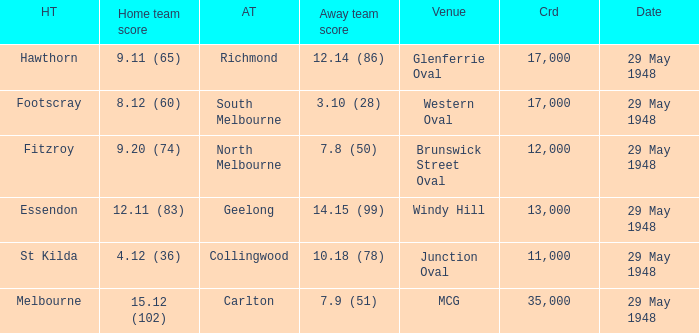In the match where footscray was the home team, how much did they score? 8.12 (60). 